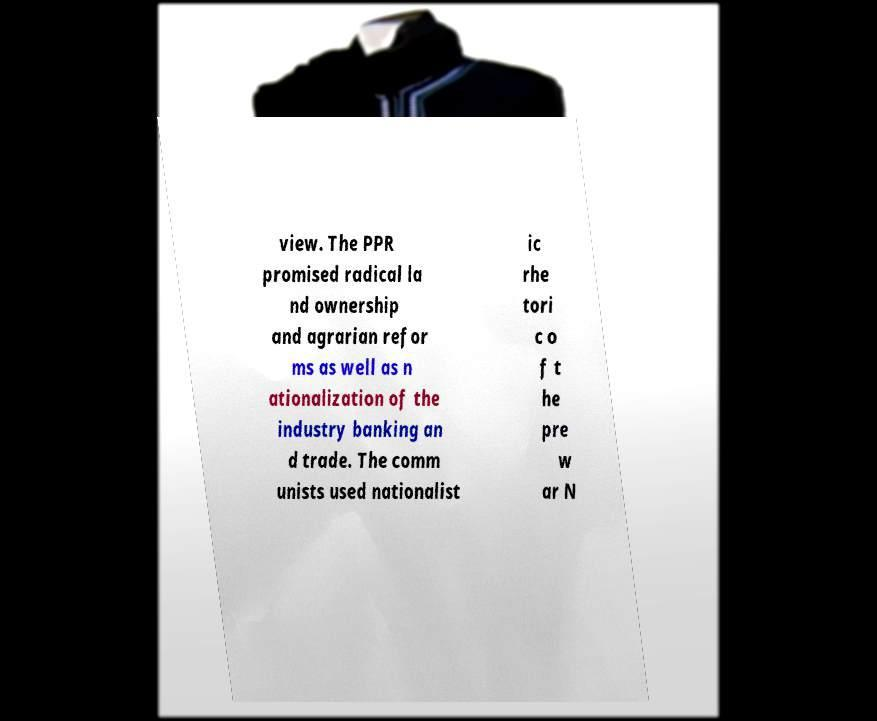For documentation purposes, I need the text within this image transcribed. Could you provide that? view. The PPR promised radical la nd ownership and agrarian refor ms as well as n ationalization of the industry banking an d trade. The comm unists used nationalist ic rhe tori c o f t he pre w ar N 